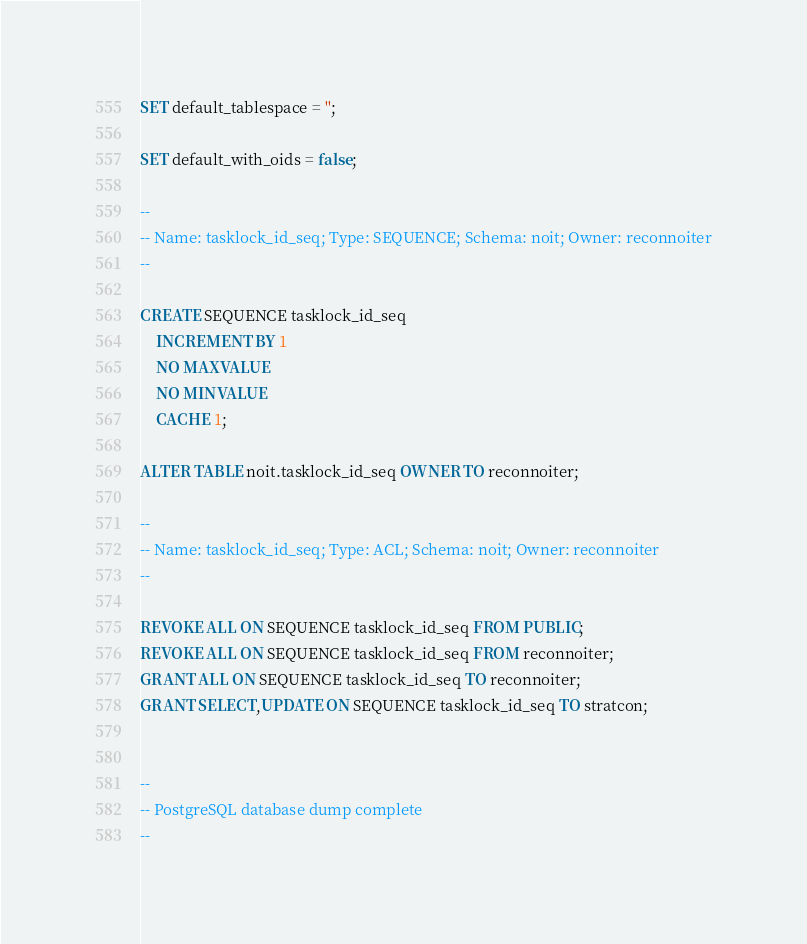Convert code to text. <code><loc_0><loc_0><loc_500><loc_500><_SQL_>SET default_tablespace = '';

SET default_with_oids = false;

--
-- Name: tasklock_id_seq; Type: SEQUENCE; Schema: noit; Owner: reconnoiter
--

CREATE SEQUENCE tasklock_id_seq
    INCREMENT BY 1
    NO MAXVALUE
    NO MINVALUE
    CACHE 1;

ALTER TABLE noit.tasklock_id_seq OWNER TO reconnoiter;

--
-- Name: tasklock_id_seq; Type: ACL; Schema: noit; Owner: reconnoiter
--

REVOKE ALL ON SEQUENCE tasklock_id_seq FROM PUBLIC;
REVOKE ALL ON SEQUENCE tasklock_id_seq FROM reconnoiter;
GRANT ALL ON SEQUENCE tasklock_id_seq TO reconnoiter;
GRANT SELECT,UPDATE ON SEQUENCE tasklock_id_seq TO stratcon;


--
-- PostgreSQL database dump complete
--

</code> 